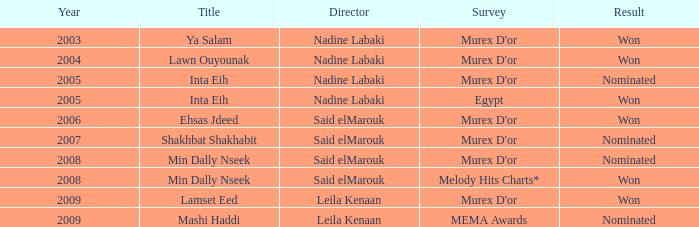What is the heading for the murex d'or assessment, after 2005, directed by said elmarouk, and earned a nomination? Shakhbat Shakhabit, Min Dally Nseek. 